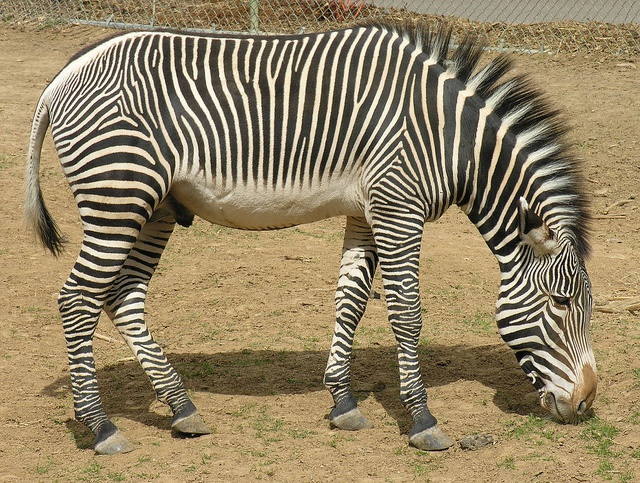Describe the objects in this image and their specific colors. I can see a zebra in tan, black, gray, and beige tones in this image. 